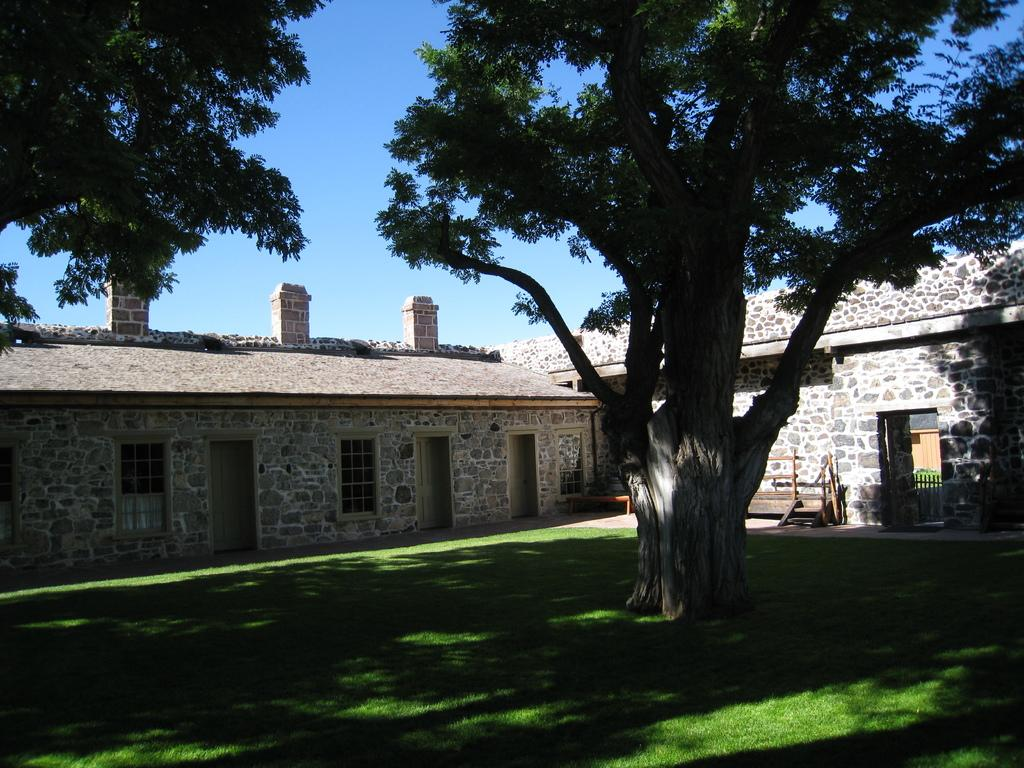What type of structures can be seen in the image? There are buildings in the image. What type of vegetation is present in the image? There are trees in the image. What type of seating is available in the image? There is a bench in the image. What type of ground covering is visible in the image? The ground is covered with grass in the image. What type of answer can be seen in the image? There is no answer present in the image. Can you see a sink in the image? There is no sink present in the image. 